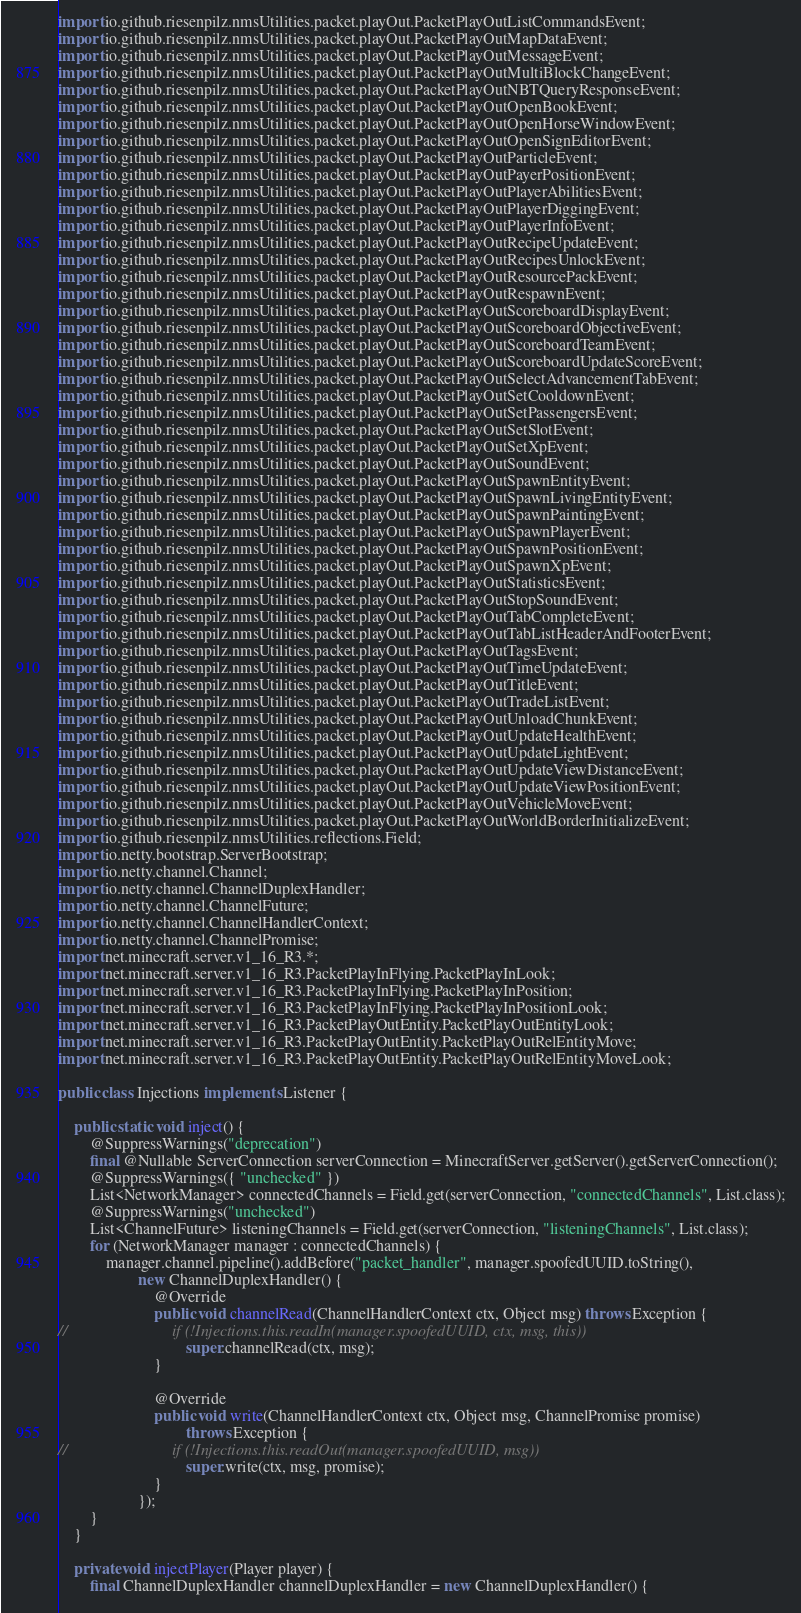Convert code to text. <code><loc_0><loc_0><loc_500><loc_500><_Java_>import io.github.riesenpilz.nmsUtilities.packet.playOut.PacketPlayOutListCommandsEvent;
import io.github.riesenpilz.nmsUtilities.packet.playOut.PacketPlayOutMapDataEvent;
import io.github.riesenpilz.nmsUtilities.packet.playOut.PacketPlayOutMessageEvent;
import io.github.riesenpilz.nmsUtilities.packet.playOut.PacketPlayOutMultiBlockChangeEvent;
import io.github.riesenpilz.nmsUtilities.packet.playOut.PacketPlayOutNBTQueryResponseEvent;
import io.github.riesenpilz.nmsUtilities.packet.playOut.PacketPlayOutOpenBookEvent;
import io.github.riesenpilz.nmsUtilities.packet.playOut.PacketPlayOutOpenHorseWindowEvent;
import io.github.riesenpilz.nmsUtilities.packet.playOut.PacketPlayOutOpenSignEditorEvent;
import io.github.riesenpilz.nmsUtilities.packet.playOut.PacketPlayOutParticleEvent;
import io.github.riesenpilz.nmsUtilities.packet.playOut.PacketPlayOutPayerPositionEvent;
import io.github.riesenpilz.nmsUtilities.packet.playOut.PacketPlayOutPlayerAbilitiesEvent;
import io.github.riesenpilz.nmsUtilities.packet.playOut.PacketPlayOutPlayerDiggingEvent;
import io.github.riesenpilz.nmsUtilities.packet.playOut.PacketPlayOutPlayerInfoEvent;
import io.github.riesenpilz.nmsUtilities.packet.playOut.PacketPlayOutRecipeUpdateEvent;
import io.github.riesenpilz.nmsUtilities.packet.playOut.PacketPlayOutRecipesUnlockEvent;
import io.github.riesenpilz.nmsUtilities.packet.playOut.PacketPlayOutResourcePackEvent;
import io.github.riesenpilz.nmsUtilities.packet.playOut.PacketPlayOutRespawnEvent;
import io.github.riesenpilz.nmsUtilities.packet.playOut.PacketPlayOutScoreboardDisplayEvent;
import io.github.riesenpilz.nmsUtilities.packet.playOut.PacketPlayOutScoreboardObjectiveEvent;
import io.github.riesenpilz.nmsUtilities.packet.playOut.PacketPlayOutScoreboardTeamEvent;
import io.github.riesenpilz.nmsUtilities.packet.playOut.PacketPlayOutScoreboardUpdateScoreEvent;
import io.github.riesenpilz.nmsUtilities.packet.playOut.PacketPlayOutSelectAdvancementTabEvent;
import io.github.riesenpilz.nmsUtilities.packet.playOut.PacketPlayOutSetCooldownEvent;
import io.github.riesenpilz.nmsUtilities.packet.playOut.PacketPlayOutSetPassengersEvent;
import io.github.riesenpilz.nmsUtilities.packet.playOut.PacketPlayOutSetSlotEvent;
import io.github.riesenpilz.nmsUtilities.packet.playOut.PacketPlayOutSetXpEvent;
import io.github.riesenpilz.nmsUtilities.packet.playOut.PacketPlayOutSoundEvent;
import io.github.riesenpilz.nmsUtilities.packet.playOut.PacketPlayOutSpawnEntityEvent;
import io.github.riesenpilz.nmsUtilities.packet.playOut.PacketPlayOutSpawnLivingEntityEvent;
import io.github.riesenpilz.nmsUtilities.packet.playOut.PacketPlayOutSpawnPaintingEvent;
import io.github.riesenpilz.nmsUtilities.packet.playOut.PacketPlayOutSpawnPlayerEvent;
import io.github.riesenpilz.nmsUtilities.packet.playOut.PacketPlayOutSpawnPositionEvent;
import io.github.riesenpilz.nmsUtilities.packet.playOut.PacketPlayOutSpawnXpEvent;
import io.github.riesenpilz.nmsUtilities.packet.playOut.PacketPlayOutStatisticsEvent;
import io.github.riesenpilz.nmsUtilities.packet.playOut.PacketPlayOutStopSoundEvent;
import io.github.riesenpilz.nmsUtilities.packet.playOut.PacketPlayOutTabCompleteEvent;
import io.github.riesenpilz.nmsUtilities.packet.playOut.PacketPlayOutTabListHeaderAndFooterEvent;
import io.github.riesenpilz.nmsUtilities.packet.playOut.PacketPlayOutTagsEvent;
import io.github.riesenpilz.nmsUtilities.packet.playOut.PacketPlayOutTimeUpdateEvent;
import io.github.riesenpilz.nmsUtilities.packet.playOut.PacketPlayOutTitleEvent;
import io.github.riesenpilz.nmsUtilities.packet.playOut.PacketPlayOutTradeListEvent;
import io.github.riesenpilz.nmsUtilities.packet.playOut.PacketPlayOutUnloadChunkEvent;
import io.github.riesenpilz.nmsUtilities.packet.playOut.PacketPlayOutUpdateHealthEvent;
import io.github.riesenpilz.nmsUtilities.packet.playOut.PacketPlayOutUpdateLightEvent;
import io.github.riesenpilz.nmsUtilities.packet.playOut.PacketPlayOutUpdateViewDistanceEvent;
import io.github.riesenpilz.nmsUtilities.packet.playOut.PacketPlayOutUpdateViewPositionEvent;
import io.github.riesenpilz.nmsUtilities.packet.playOut.PacketPlayOutVehicleMoveEvent;
import io.github.riesenpilz.nmsUtilities.packet.playOut.PacketPlayOutWorldBorderInitializeEvent;
import io.github.riesenpilz.nmsUtilities.reflections.Field;
import io.netty.bootstrap.ServerBootstrap;
import io.netty.channel.Channel;
import io.netty.channel.ChannelDuplexHandler;
import io.netty.channel.ChannelFuture;
import io.netty.channel.ChannelHandlerContext;
import io.netty.channel.ChannelPromise;
import net.minecraft.server.v1_16_R3.*;
import net.minecraft.server.v1_16_R3.PacketPlayInFlying.PacketPlayInLook;
import net.minecraft.server.v1_16_R3.PacketPlayInFlying.PacketPlayInPosition;
import net.minecraft.server.v1_16_R3.PacketPlayInFlying.PacketPlayInPositionLook;
import net.minecraft.server.v1_16_R3.PacketPlayOutEntity.PacketPlayOutEntityLook;
import net.minecraft.server.v1_16_R3.PacketPlayOutEntity.PacketPlayOutRelEntityMove;
import net.minecraft.server.v1_16_R3.PacketPlayOutEntity.PacketPlayOutRelEntityMoveLook;

public class Injections implements Listener {

	public static void inject() {
		@SuppressWarnings("deprecation")
		final @Nullable ServerConnection serverConnection = MinecraftServer.getServer().getServerConnection();
		@SuppressWarnings({ "unchecked" })
		List<NetworkManager> connectedChannels = Field.get(serverConnection, "connectedChannels", List.class);
		@SuppressWarnings("unchecked")
		List<ChannelFuture> listeningChannels = Field.get(serverConnection, "listeningChannels", List.class);
		for (NetworkManager manager : connectedChannels) {
			manager.channel.pipeline().addBefore("packet_handler", manager.spoofedUUID.toString(),
					new ChannelDuplexHandler() {
						@Override
						public void channelRead(ChannelHandlerContext ctx, Object msg) throws Exception {
//							if (!Injections.this.readIn(manager.spoofedUUID, ctx, msg, this))
								super.channelRead(ctx, msg);
						}

						@Override
						public void write(ChannelHandlerContext ctx, Object msg, ChannelPromise promise)
								throws Exception {
//							if (!Injections.this.readOut(manager.spoofedUUID, msg))
								super.write(ctx, msg, promise);
						}
					});
		}
	}

	private void injectPlayer(Player player) {
		final ChannelDuplexHandler channelDuplexHandler = new ChannelDuplexHandler() {</code> 